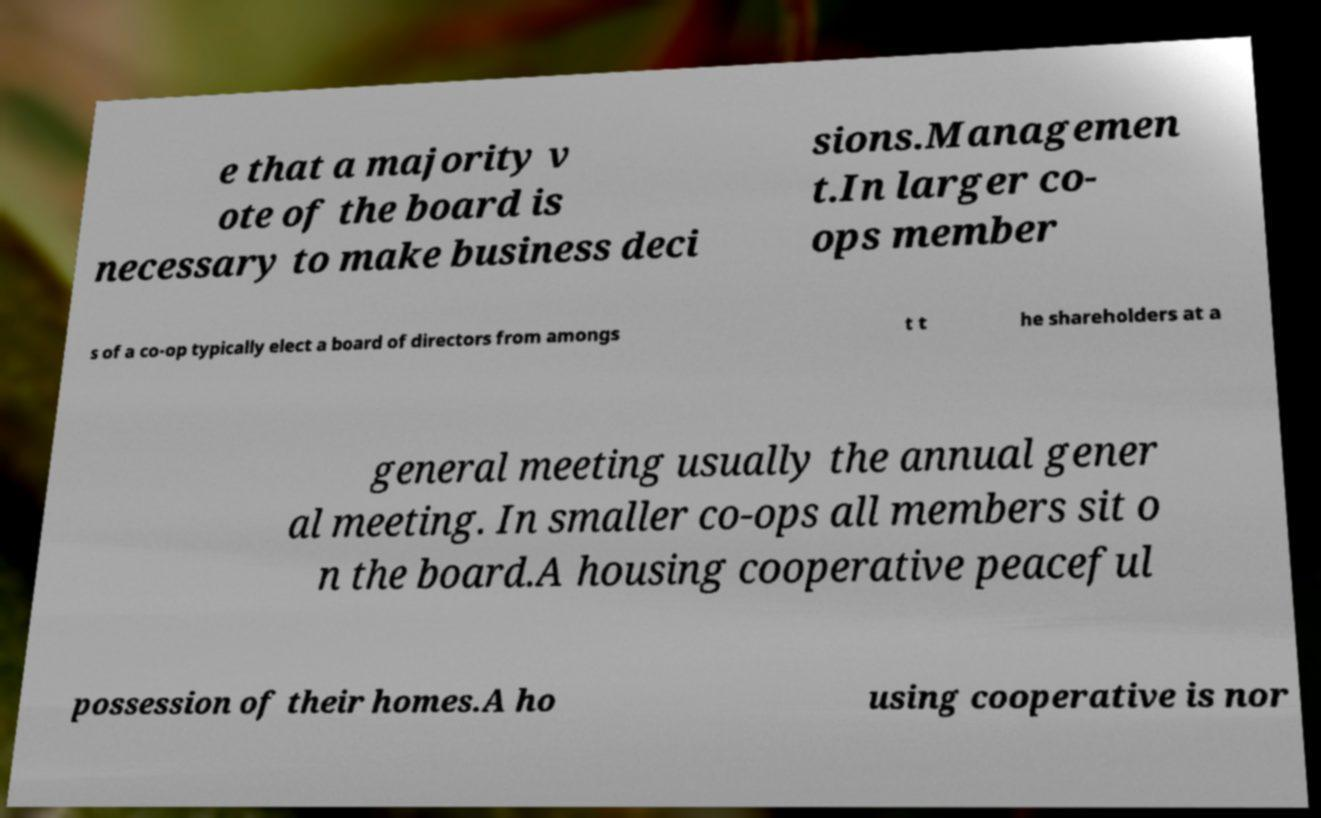I need the written content from this picture converted into text. Can you do that? e that a majority v ote of the board is necessary to make business deci sions.Managemen t.In larger co- ops member s of a co-op typically elect a board of directors from amongs t t he shareholders at a general meeting usually the annual gener al meeting. In smaller co-ops all members sit o n the board.A housing cooperative peaceful possession of their homes.A ho using cooperative is nor 